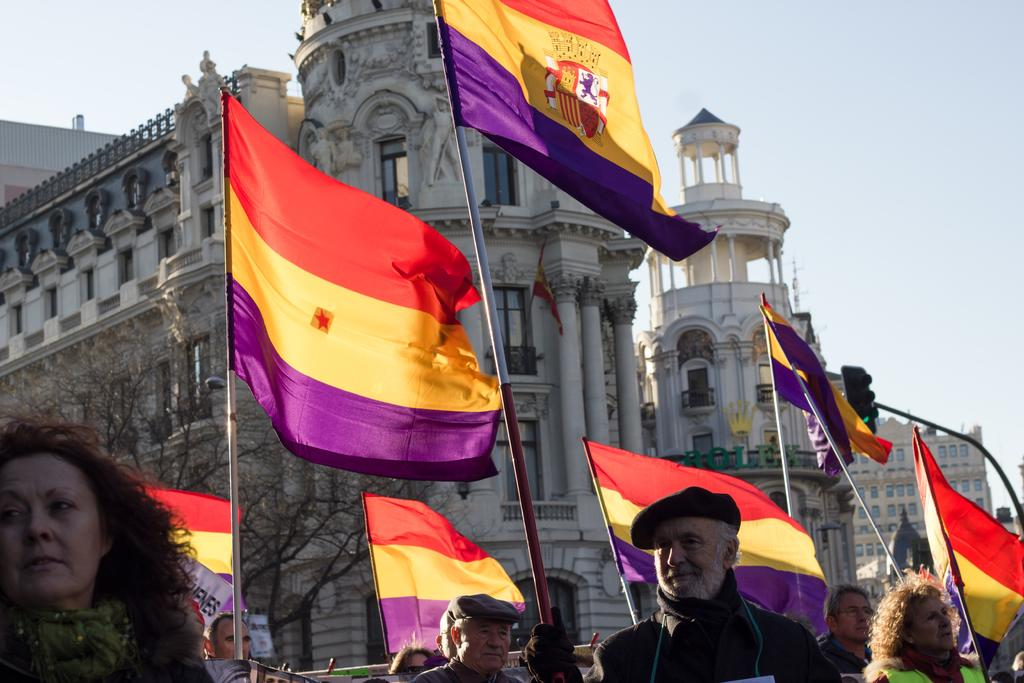What are the people in the image doing? The people in the image are standing and holding poles with flags. What can be seen in the background of the image? There are buildings present in the background of the image. What is the condition of the sky in the image? The sky is clear in the image. What book is the person reading in the image? There is no book present in the image; the people are holding poles with flags. Why is the person crying in the image? There is no person crying in the image; the people are standing and holding poles with flags. 